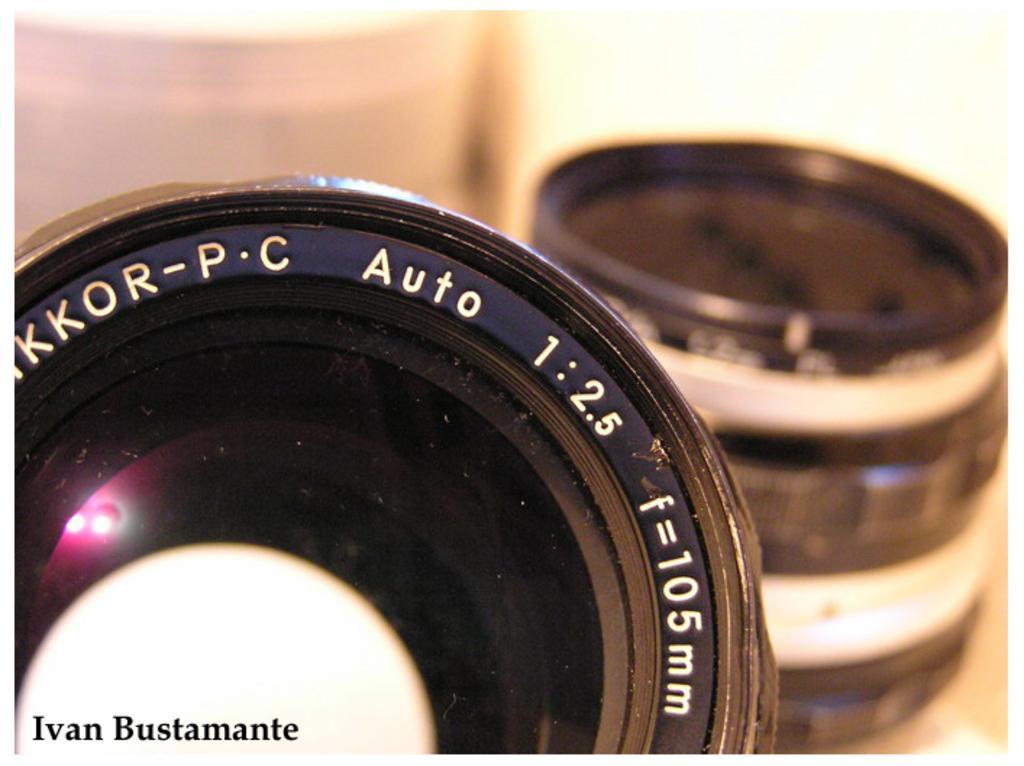Describe this image in one or two sentences. In this image we can see camera lens. Left side bottom of the image there is a watermark. Background it is blur. 